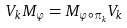Convert formula to latex. <formula><loc_0><loc_0><loc_500><loc_500>V _ { k } M _ { \varphi } = M _ { \varphi \circ \pi _ { k } } V _ { k }</formula> 